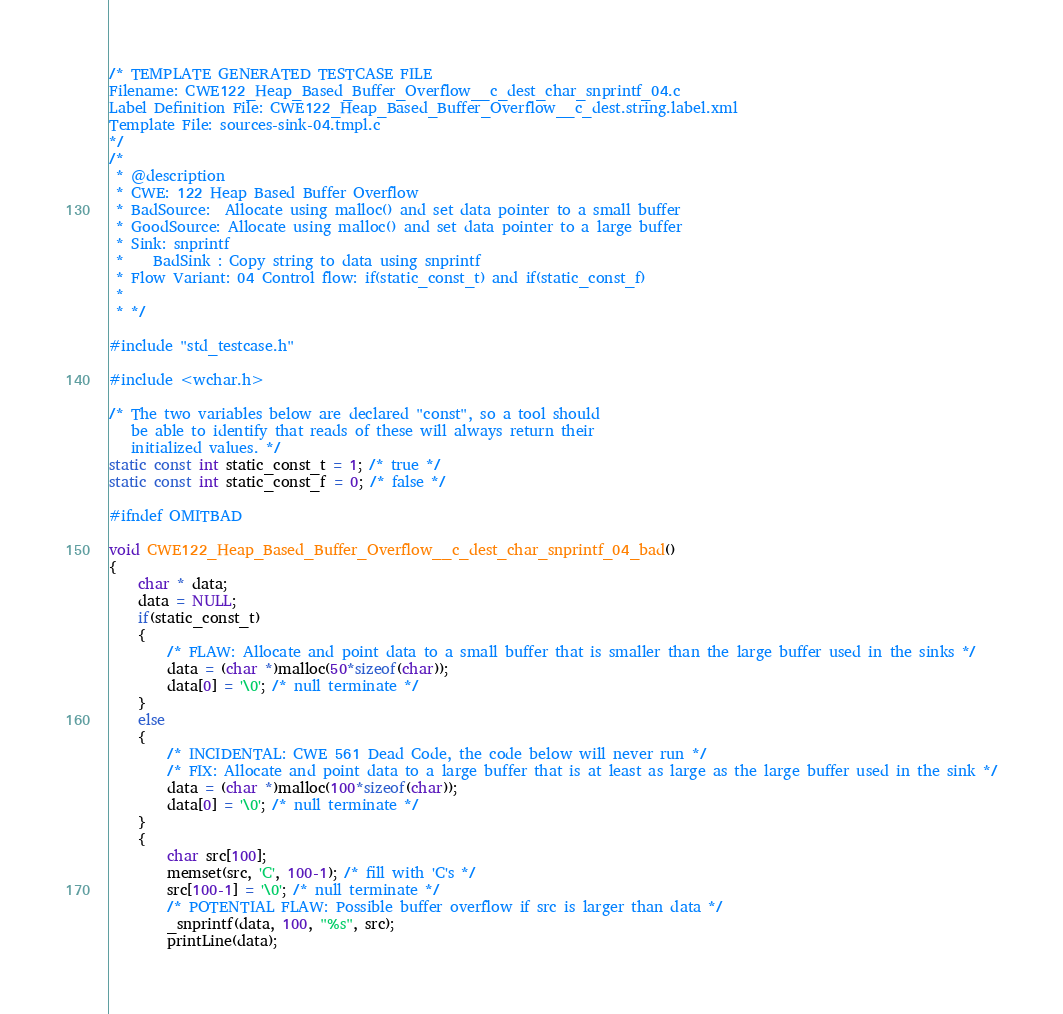<code> <loc_0><loc_0><loc_500><loc_500><_C_>/* TEMPLATE GENERATED TESTCASE FILE
Filename: CWE122_Heap_Based_Buffer_Overflow__c_dest_char_snprintf_04.c
Label Definition File: CWE122_Heap_Based_Buffer_Overflow__c_dest.string.label.xml
Template File: sources-sink-04.tmpl.c
*/
/*
 * @description
 * CWE: 122 Heap Based Buffer Overflow
 * BadSource:  Allocate using malloc() and set data pointer to a small buffer
 * GoodSource: Allocate using malloc() and set data pointer to a large buffer
 * Sink: snprintf
 *    BadSink : Copy string to data using snprintf
 * Flow Variant: 04 Control flow: if(static_const_t) and if(static_const_f)
 *
 * */

#include "std_testcase.h"

#include <wchar.h>

/* The two variables below are declared "const", so a tool should
   be able to identify that reads of these will always return their
   initialized values. */
static const int static_const_t = 1; /* true */
static const int static_const_f = 0; /* false */

#ifndef OMITBAD

void CWE122_Heap_Based_Buffer_Overflow__c_dest_char_snprintf_04_bad()
{
    char * data;
    data = NULL;
    if(static_const_t)
    {
        /* FLAW: Allocate and point data to a small buffer that is smaller than the large buffer used in the sinks */
        data = (char *)malloc(50*sizeof(char));
        data[0] = '\0'; /* null terminate */
    }
    else
    {
        /* INCIDENTAL: CWE 561 Dead Code, the code below will never run */
        /* FIX: Allocate and point data to a large buffer that is at least as large as the large buffer used in the sink */
        data = (char *)malloc(100*sizeof(char));
        data[0] = '\0'; /* null terminate */
    }
    {
        char src[100];
        memset(src, 'C', 100-1); /* fill with 'C's */
        src[100-1] = '\0'; /* null terminate */
        /* POTENTIAL FLAW: Possible buffer overflow if src is larger than data */
        _snprintf(data, 100, "%s", src);
        printLine(data);</code> 